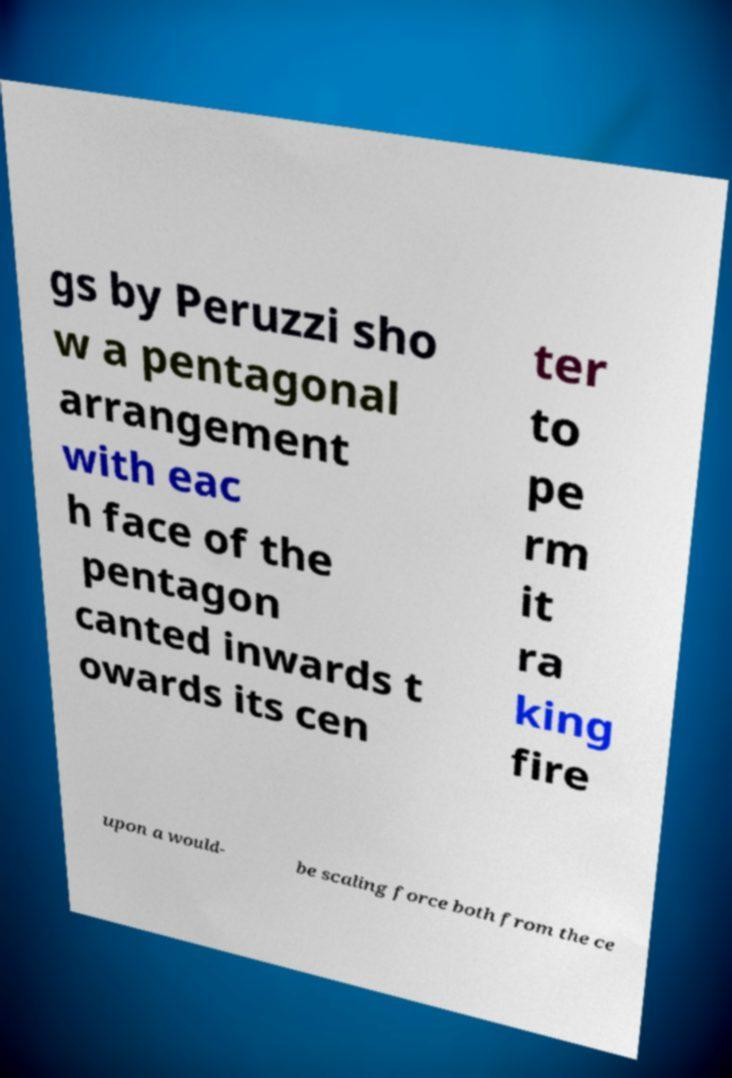Could you assist in decoding the text presented in this image and type it out clearly? gs by Peruzzi sho w a pentagonal arrangement with eac h face of the pentagon canted inwards t owards its cen ter to pe rm it ra king fire upon a would- be scaling force both from the ce 